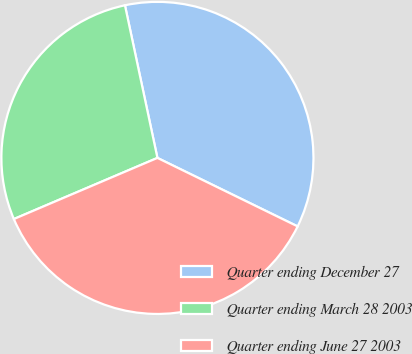Convert chart. <chart><loc_0><loc_0><loc_500><loc_500><pie_chart><fcel>Quarter ending December 27<fcel>Quarter ending March 28 2003<fcel>Quarter ending June 27 2003<nl><fcel>35.57%<fcel>28.07%<fcel>36.36%<nl></chart> 